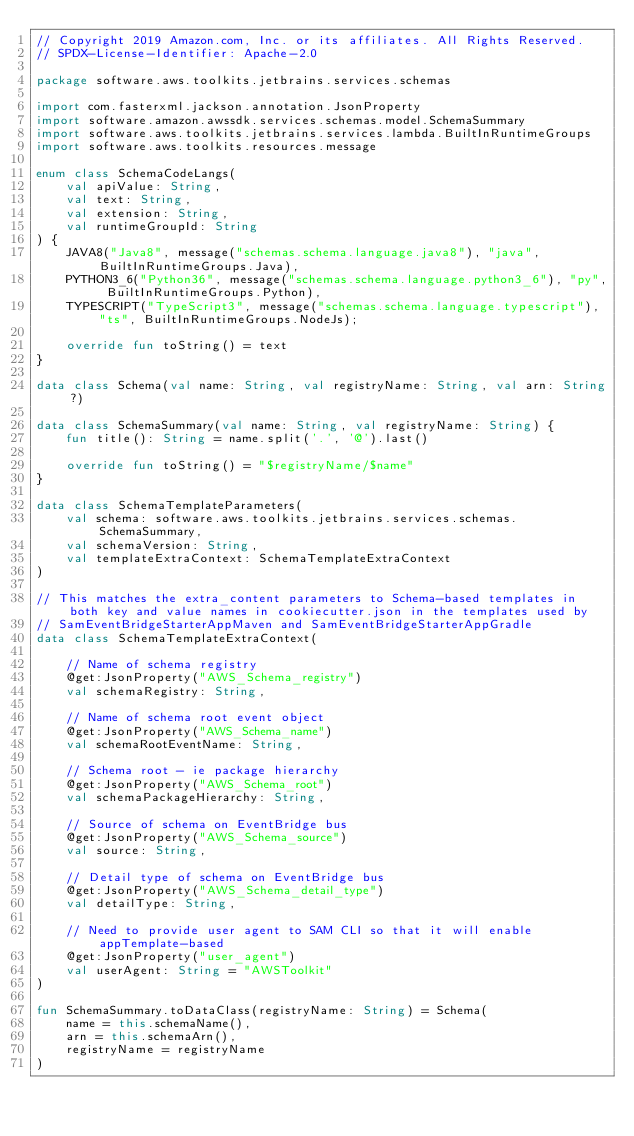Convert code to text. <code><loc_0><loc_0><loc_500><loc_500><_Kotlin_>// Copyright 2019 Amazon.com, Inc. or its affiliates. All Rights Reserved.
// SPDX-License-Identifier: Apache-2.0

package software.aws.toolkits.jetbrains.services.schemas

import com.fasterxml.jackson.annotation.JsonProperty
import software.amazon.awssdk.services.schemas.model.SchemaSummary
import software.aws.toolkits.jetbrains.services.lambda.BuiltInRuntimeGroups
import software.aws.toolkits.resources.message

enum class SchemaCodeLangs(
    val apiValue: String,
    val text: String,
    val extension: String,
    val runtimeGroupId: String
) {
    JAVA8("Java8", message("schemas.schema.language.java8"), "java", BuiltInRuntimeGroups.Java),
    PYTHON3_6("Python36", message("schemas.schema.language.python3_6"), "py", BuiltInRuntimeGroups.Python),
    TYPESCRIPT("TypeScript3", message("schemas.schema.language.typescript"), "ts", BuiltInRuntimeGroups.NodeJs);

    override fun toString() = text
}

data class Schema(val name: String, val registryName: String, val arn: String?)

data class SchemaSummary(val name: String, val registryName: String) {
    fun title(): String = name.split('.', '@').last()

    override fun toString() = "$registryName/$name"
}

data class SchemaTemplateParameters(
    val schema: software.aws.toolkits.jetbrains.services.schemas.SchemaSummary,
    val schemaVersion: String,
    val templateExtraContext: SchemaTemplateExtraContext
)

// This matches the extra_content parameters to Schema-based templates in both key and value names in cookiecutter.json in the templates used by
// SamEventBridgeStarterAppMaven and SamEventBridgeStarterAppGradle
data class SchemaTemplateExtraContext(

    // Name of schema registry
    @get:JsonProperty("AWS_Schema_registry")
    val schemaRegistry: String,

    // Name of schema root event object
    @get:JsonProperty("AWS_Schema_name")
    val schemaRootEventName: String,

    // Schema root - ie package hierarchy
    @get:JsonProperty("AWS_Schema_root")
    val schemaPackageHierarchy: String,

    // Source of schema on EventBridge bus
    @get:JsonProperty("AWS_Schema_source")
    val source: String,

    // Detail type of schema on EventBridge bus
    @get:JsonProperty("AWS_Schema_detail_type")
    val detailType: String,

    // Need to provide user agent to SAM CLI so that it will enable appTemplate-based
    @get:JsonProperty("user_agent")
    val userAgent: String = "AWSToolkit"
)

fun SchemaSummary.toDataClass(registryName: String) = Schema(
    name = this.schemaName(),
    arn = this.schemaArn(),
    registryName = registryName
)
</code> 